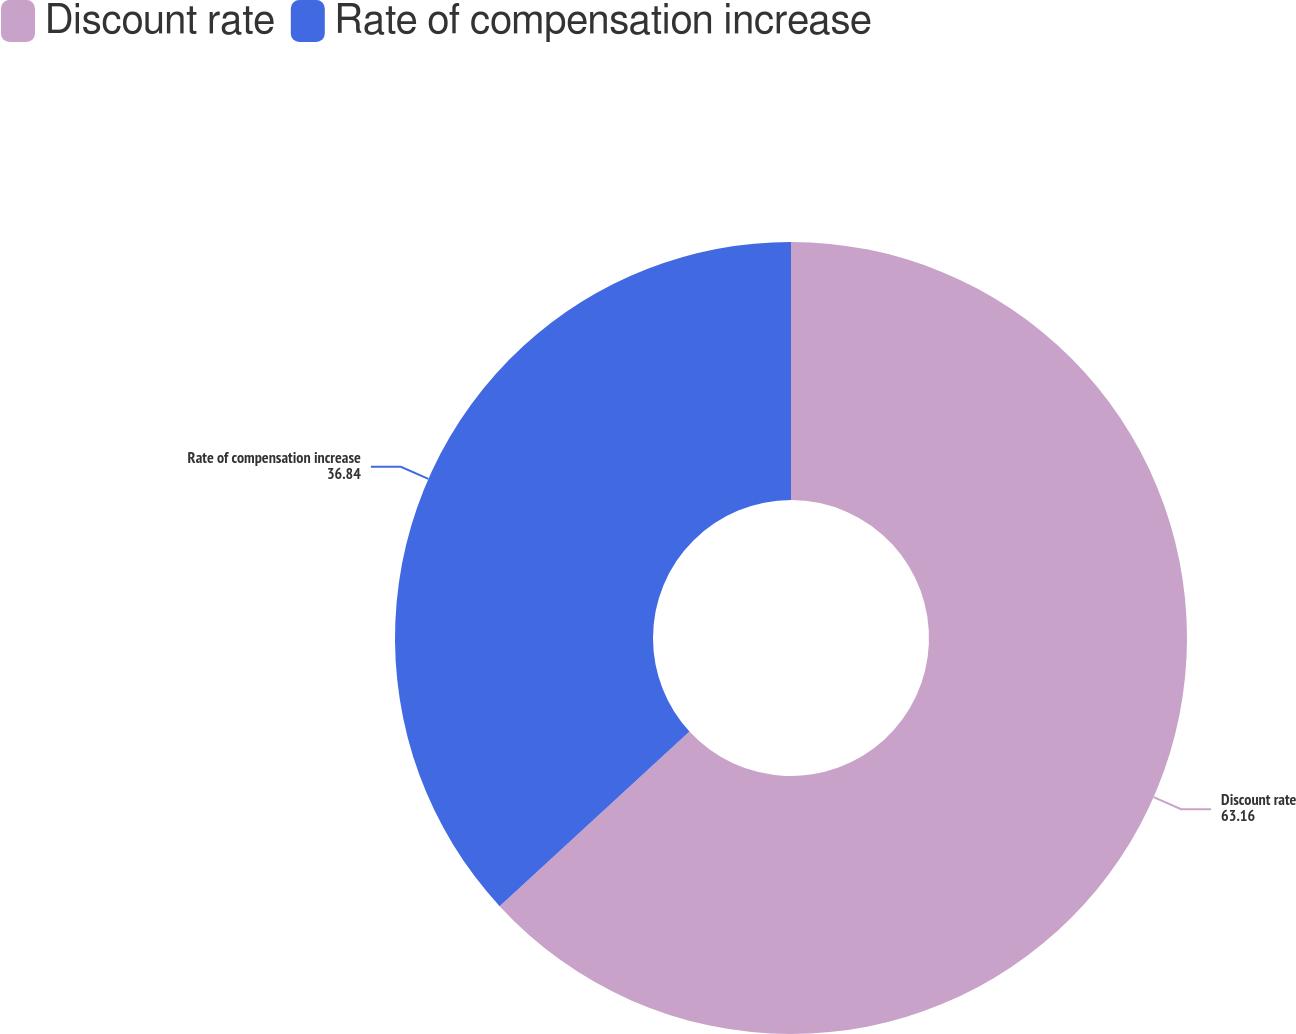Convert chart to OTSL. <chart><loc_0><loc_0><loc_500><loc_500><pie_chart><fcel>Discount rate<fcel>Rate of compensation increase<nl><fcel>63.16%<fcel>36.84%<nl></chart> 